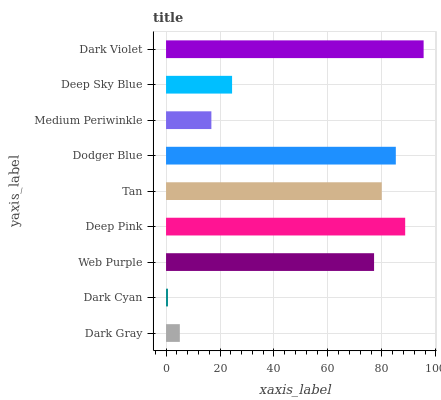Is Dark Cyan the minimum?
Answer yes or no. Yes. Is Dark Violet the maximum?
Answer yes or no. Yes. Is Web Purple the minimum?
Answer yes or no. No. Is Web Purple the maximum?
Answer yes or no. No. Is Web Purple greater than Dark Cyan?
Answer yes or no. Yes. Is Dark Cyan less than Web Purple?
Answer yes or no. Yes. Is Dark Cyan greater than Web Purple?
Answer yes or no. No. Is Web Purple less than Dark Cyan?
Answer yes or no. No. Is Web Purple the high median?
Answer yes or no. Yes. Is Web Purple the low median?
Answer yes or no. Yes. Is Deep Sky Blue the high median?
Answer yes or no. No. Is Tan the low median?
Answer yes or no. No. 